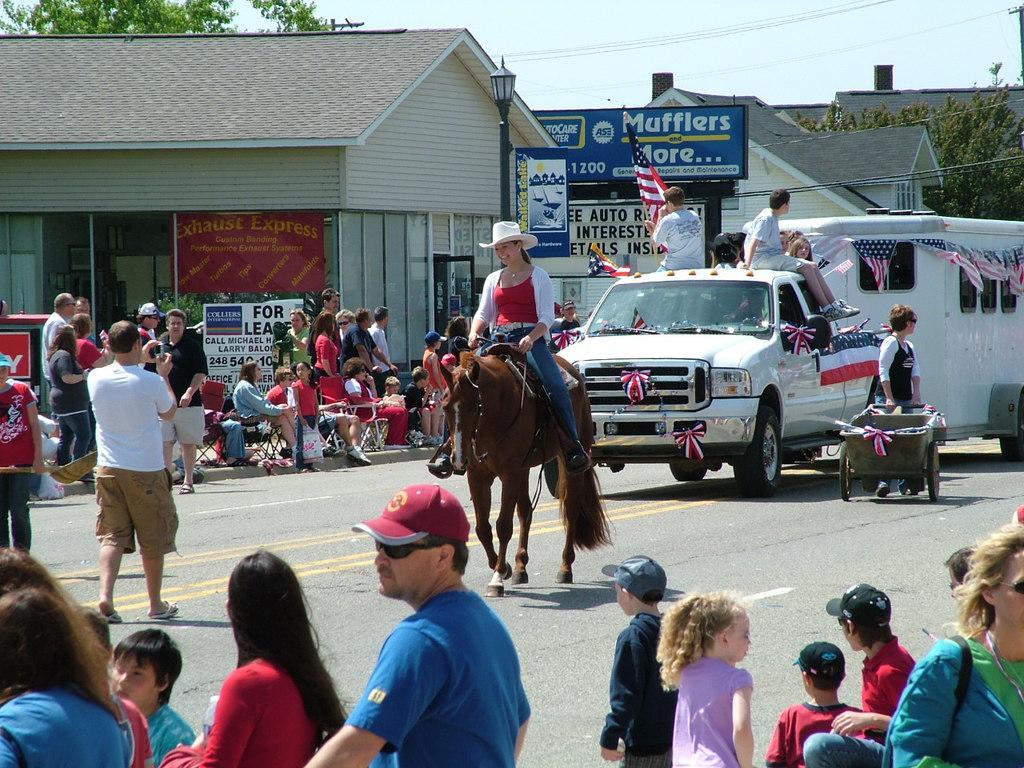How would you summarize this image in a sentence or two? In this image there is a lady riding a horse and vehicles are moving on a road and people are sitting on footpaths and few are standing, in the background there are houses, light poles, trees and the sky. 